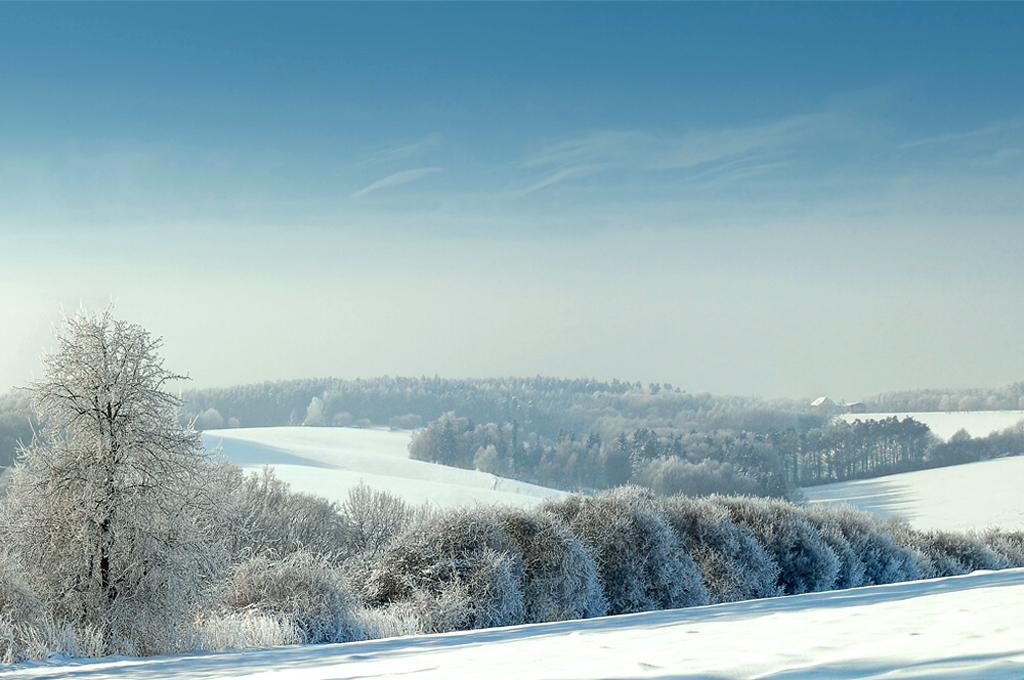What type of vegetation can be seen in the image? There are trees in the image. What is covering the trees in the image? The trees are covered with snow. What can be seen in the background of the image? The sky is visible in the background of the image. What colors are present in the sky? The sky has a combination of white and blue colors. Can you hear the bells ringing from the giraffe in the image? There is no giraffe or bells present in the image, so it is not possible to hear any ringing. 